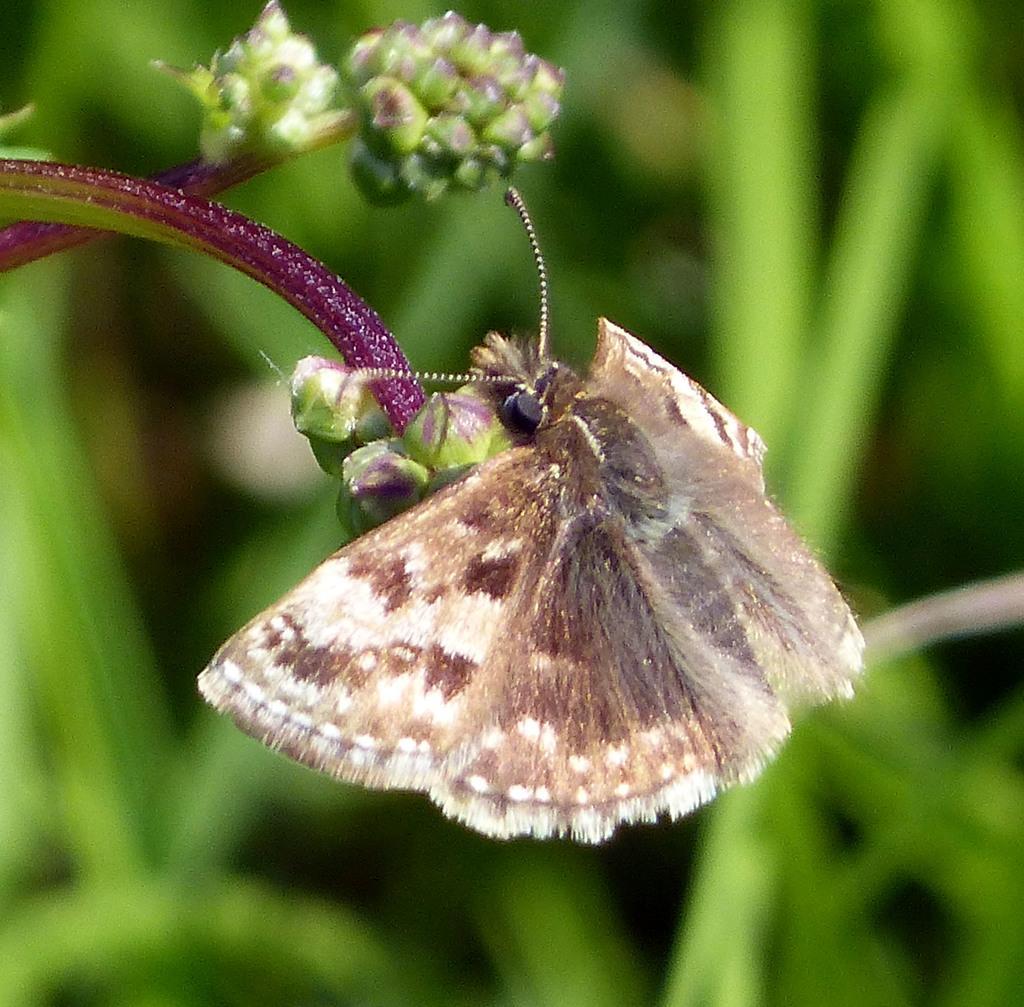Could you give a brief overview of what you see in this image? In this image there is a butterfly eating the flowers. In the background there are green leaves. 